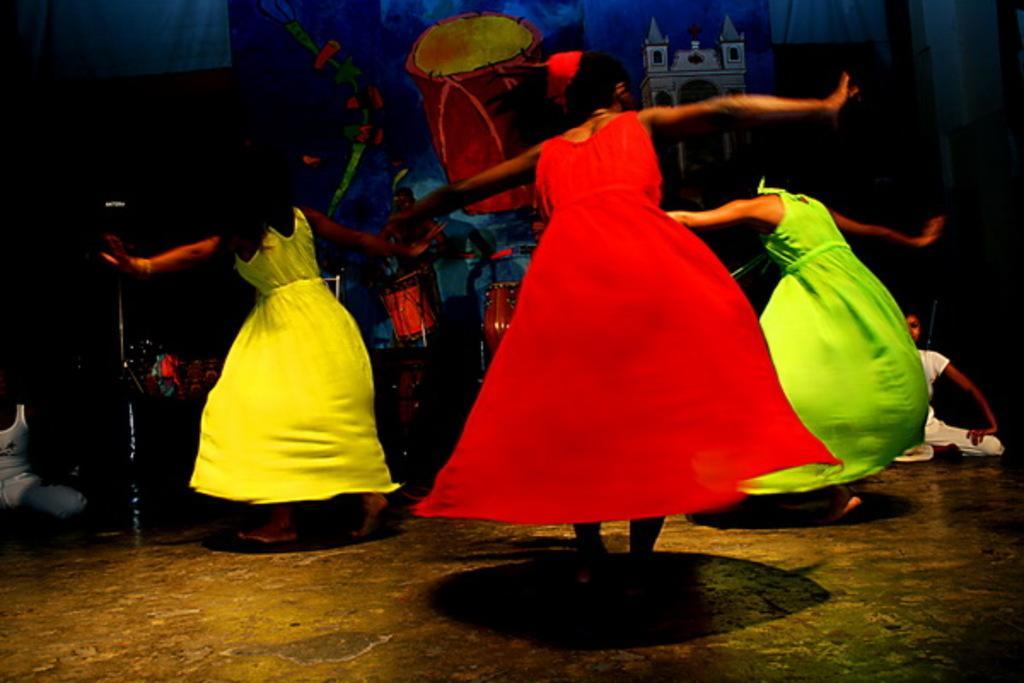Please provide a concise description of this image. These three women wore frock and dancing. Background there are musical drums. On this banner there is a musical drum and a building. Here we can see two people. 